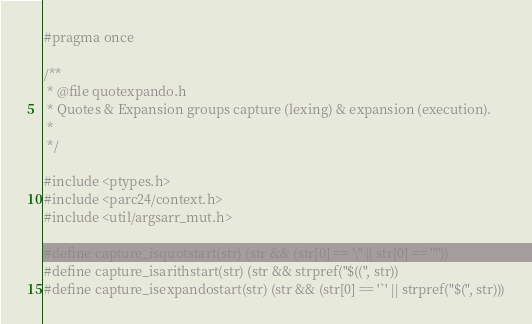<code> <loc_0><loc_0><loc_500><loc_500><_C_>#pragma once

/**
 * @file quotexpando.h
 * Quotes & Expansion groups capture (lexing) & expansion (execution).
 * 
 */

#include <ptypes.h>
#include <parc24/context.h>
#include <util/argsarr_mut.h>

#define capture_isquotstart(str) (str && (str[0] == '\'' || str[0] == '"'))
#define capture_isarithstart(str) (str && strpref("$((", str))
#define capture_isexpandostart(str) (str && (str[0] == '`' || strpref("$(", str)))</code> 